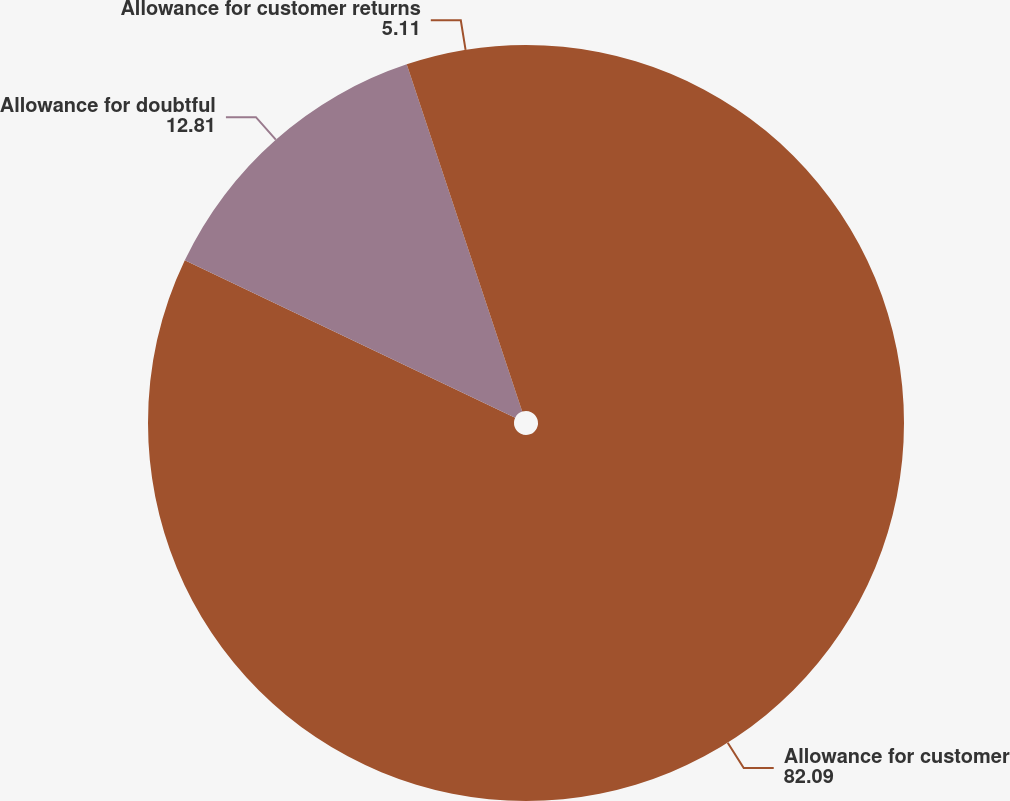Convert chart to OTSL. <chart><loc_0><loc_0><loc_500><loc_500><pie_chart><fcel>Allowance for customer<fcel>Allowance for doubtful<fcel>Allowance for customer returns<nl><fcel>82.09%<fcel>12.81%<fcel>5.11%<nl></chart> 